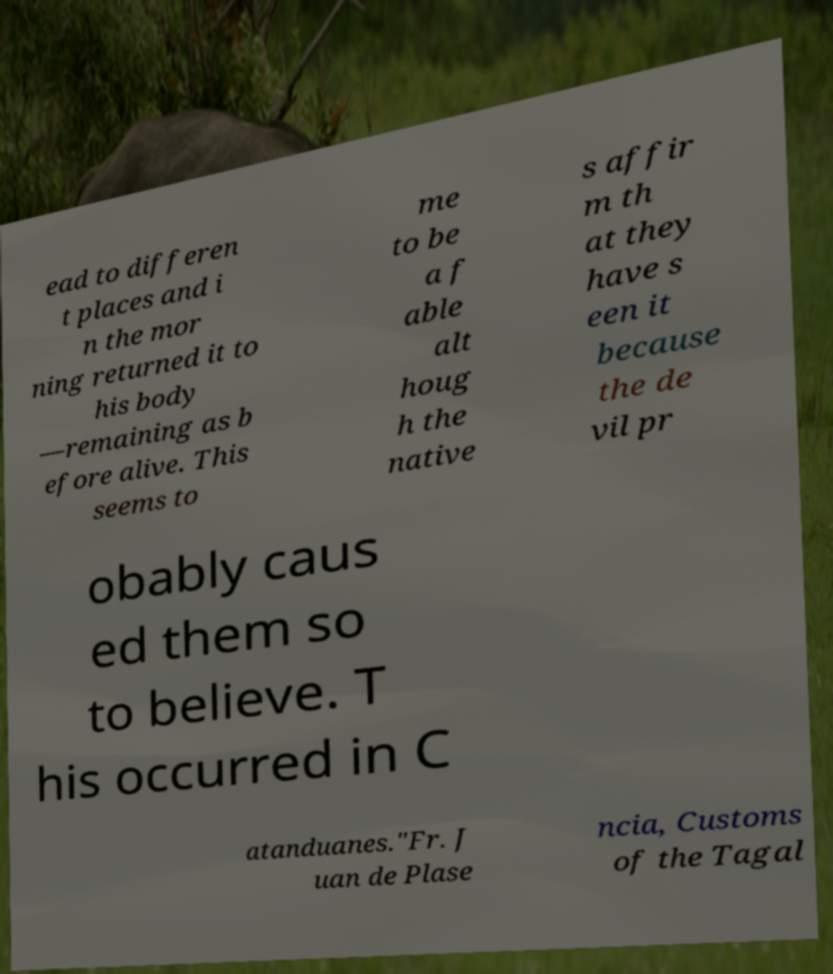Please read and relay the text visible in this image. What does it say? ead to differen t places and i n the mor ning returned it to his body —remaining as b efore alive. This seems to me to be a f able alt houg h the native s affir m th at they have s een it because the de vil pr obably caus ed them so to believe. T his occurred in C atanduanes."Fr. J uan de Plase ncia, Customs of the Tagal 